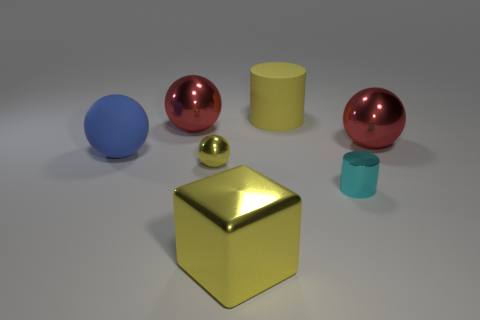There is a small shiny sphere; is it the same color as the big matte thing that is on the right side of the big matte sphere?
Your response must be concise. Yes. There is a big thing that is the same color as the big cylinder; what is its material?
Make the answer very short. Metal. What is the size of the blue matte thing?
Your answer should be very brief. Large. What is the color of the cube that is the same material as the tiny sphere?
Provide a succinct answer. Yellow. How big is the yellow thing that is behind the blue object?
Offer a very short reply. Large. Is the color of the large cube the same as the big cylinder?
Provide a succinct answer. Yes. There is a big matte thing to the right of the blue ball; how many metallic balls are behind it?
Make the answer very short. 0. What is the size of the red metallic thing that is in front of the big red metallic thing that is to the left of the large metallic object that is to the right of the tiny cyan shiny thing?
Offer a terse response. Large. There is a metal ball that is right of the small yellow object; does it have the same color as the small metallic cylinder?
Ensure brevity in your answer.  No. There is a cyan object that is the same shape as the large yellow matte thing; what size is it?
Offer a very short reply. Small. 